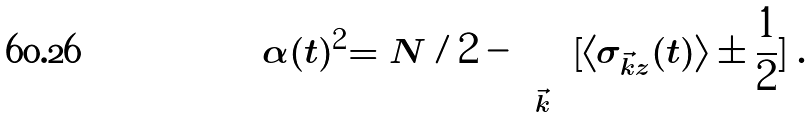<formula> <loc_0><loc_0><loc_500><loc_500>\alpha ( t ) ^ { 2 } = N / 2 - \sum _ { \vec { k } } [ \langle \sigma _ { \vec { k } z } ( t ) \rangle \pm \frac { 1 } { 2 } ] \, .</formula> 